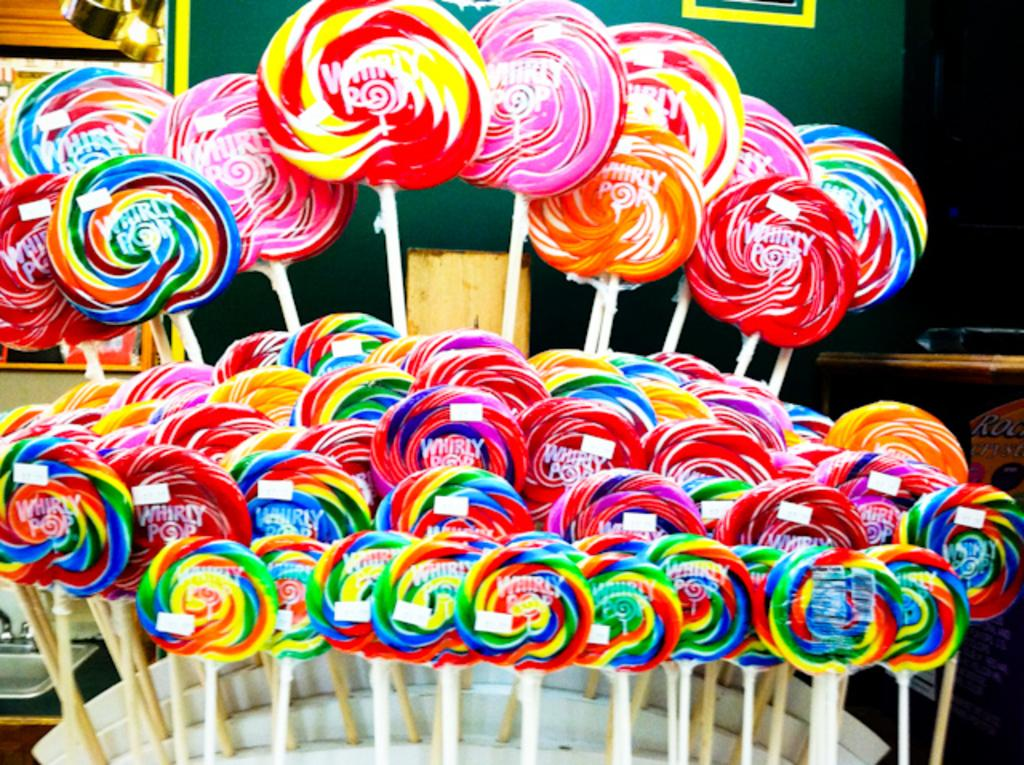What type of sweets can be seen in the image? There are lollipops in the image. What is visible in the background of the image? There is a wall in the background of the image. How many cherries are hanging from the lollipops in the image? There are no cherries present in the image; it features lollipops. What type of trade is being conducted in the image? There is no trade being conducted in the image; it features lollipops and a wall in the background. 